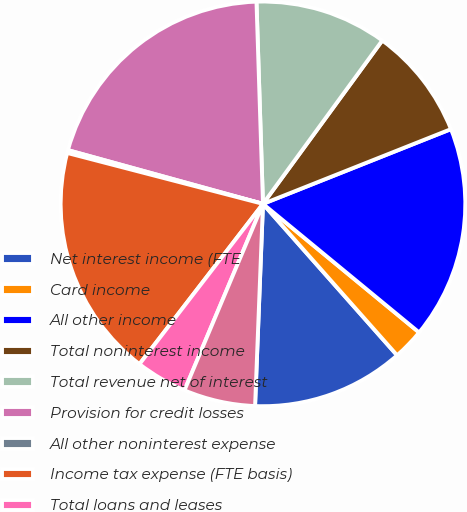Convert chart. <chart><loc_0><loc_0><loc_500><loc_500><pie_chart><fcel>Net interest income (FTE<fcel>Card income<fcel>All other income<fcel>Total noninterest income<fcel>Total revenue net of interest<fcel>Provision for credit losses<fcel>All other noninterest expense<fcel>Income tax expense (FTE basis)<fcel>Total loans and leases<fcel>Total earning assets<nl><fcel>12.16%<fcel>2.5%<fcel>16.99%<fcel>8.94%<fcel>10.55%<fcel>20.21%<fcel>0.23%<fcel>18.6%<fcel>4.11%<fcel>5.72%<nl></chart> 